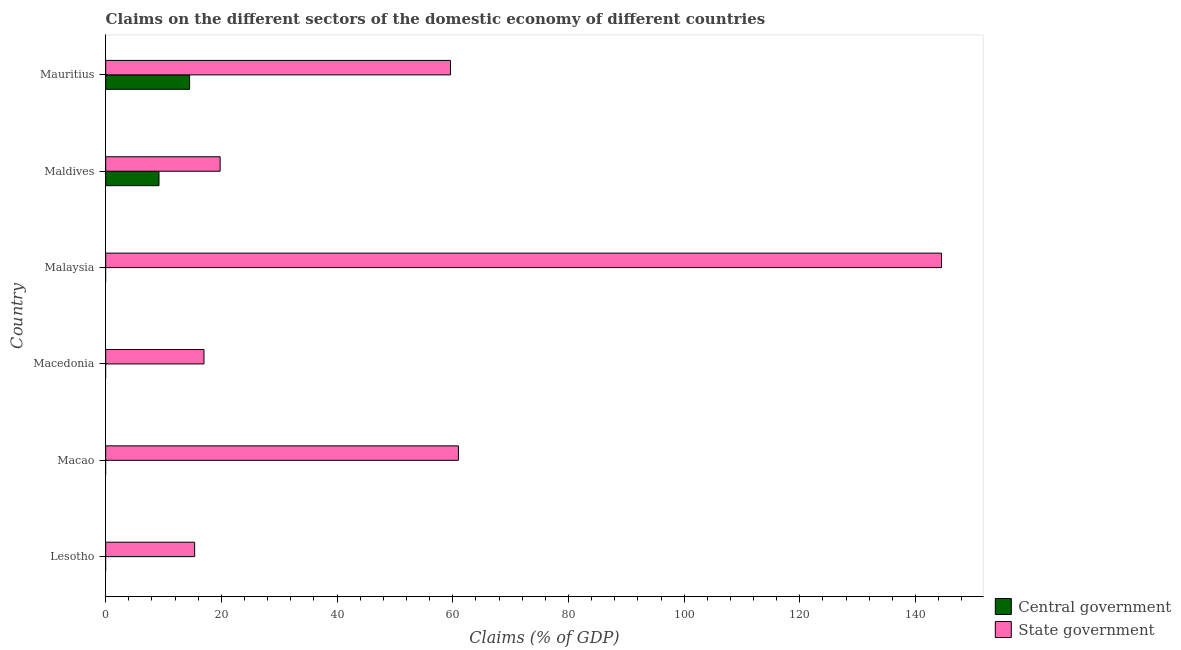How many different coloured bars are there?
Make the answer very short. 2. Are the number of bars on each tick of the Y-axis equal?
Offer a very short reply. No. What is the label of the 6th group of bars from the top?
Make the answer very short. Lesotho. In how many cases, is the number of bars for a given country not equal to the number of legend labels?
Your answer should be very brief. 4. What is the claims on state government in Malaysia?
Offer a terse response. 144.49. Across all countries, what is the maximum claims on state government?
Offer a very short reply. 144.49. In which country was the claims on state government maximum?
Provide a succinct answer. Malaysia. What is the total claims on state government in the graph?
Ensure brevity in your answer.  317.22. What is the difference between the claims on state government in Lesotho and that in Macedonia?
Provide a succinct answer. -1.61. What is the difference between the claims on state government in Malaysia and the claims on central government in Macao?
Provide a short and direct response. 144.49. What is the average claims on central government per country?
Make the answer very short. 3.95. What is the difference between the claims on central government and claims on state government in Mauritius?
Your response must be concise. -45.1. What is the ratio of the claims on state government in Malaysia to that in Mauritius?
Your response must be concise. 2.42. What is the difference between the highest and the second highest claims on state government?
Ensure brevity in your answer.  83.51. What is the difference between the highest and the lowest claims on state government?
Your response must be concise. 129.11. Is the sum of the claims on state government in Macao and Maldives greater than the maximum claims on central government across all countries?
Keep it short and to the point. Yes. How many bars are there?
Your answer should be very brief. 8. How many countries are there in the graph?
Your response must be concise. 6. Does the graph contain grids?
Keep it short and to the point. No. Where does the legend appear in the graph?
Your answer should be compact. Bottom right. How many legend labels are there?
Make the answer very short. 2. What is the title of the graph?
Your response must be concise. Claims on the different sectors of the domestic economy of different countries. What is the label or title of the X-axis?
Keep it short and to the point. Claims (% of GDP). What is the Claims (% of GDP) of State government in Lesotho?
Make the answer very short. 15.38. What is the Claims (% of GDP) of Central government in Macao?
Provide a succinct answer. 0. What is the Claims (% of GDP) of State government in Macao?
Offer a terse response. 60.98. What is the Claims (% of GDP) of Central government in Macedonia?
Offer a terse response. 0. What is the Claims (% of GDP) of State government in Macedonia?
Ensure brevity in your answer.  16.99. What is the Claims (% of GDP) in State government in Malaysia?
Give a very brief answer. 144.49. What is the Claims (% of GDP) in Central government in Maldives?
Ensure brevity in your answer.  9.21. What is the Claims (% of GDP) of State government in Maldives?
Provide a short and direct response. 19.78. What is the Claims (% of GDP) of Central government in Mauritius?
Keep it short and to the point. 14.51. What is the Claims (% of GDP) of State government in Mauritius?
Provide a short and direct response. 59.6. Across all countries, what is the maximum Claims (% of GDP) in Central government?
Your answer should be compact. 14.51. Across all countries, what is the maximum Claims (% of GDP) of State government?
Your answer should be compact. 144.49. Across all countries, what is the minimum Claims (% of GDP) of State government?
Offer a terse response. 15.38. What is the total Claims (% of GDP) in Central government in the graph?
Make the answer very short. 23.72. What is the total Claims (% of GDP) of State government in the graph?
Keep it short and to the point. 317.22. What is the difference between the Claims (% of GDP) of State government in Lesotho and that in Macao?
Provide a succinct answer. -45.6. What is the difference between the Claims (% of GDP) of State government in Lesotho and that in Macedonia?
Ensure brevity in your answer.  -1.61. What is the difference between the Claims (% of GDP) of State government in Lesotho and that in Malaysia?
Your answer should be compact. -129.11. What is the difference between the Claims (% of GDP) of State government in Lesotho and that in Maldives?
Ensure brevity in your answer.  -4.4. What is the difference between the Claims (% of GDP) of State government in Lesotho and that in Mauritius?
Offer a very short reply. -44.22. What is the difference between the Claims (% of GDP) of State government in Macao and that in Macedonia?
Offer a terse response. 43.99. What is the difference between the Claims (% of GDP) in State government in Macao and that in Malaysia?
Your answer should be compact. -83.51. What is the difference between the Claims (% of GDP) of State government in Macao and that in Maldives?
Your response must be concise. 41.2. What is the difference between the Claims (% of GDP) in State government in Macao and that in Mauritius?
Your answer should be very brief. 1.37. What is the difference between the Claims (% of GDP) in State government in Macedonia and that in Malaysia?
Keep it short and to the point. -127.5. What is the difference between the Claims (% of GDP) of State government in Macedonia and that in Maldives?
Ensure brevity in your answer.  -2.79. What is the difference between the Claims (% of GDP) in State government in Macedonia and that in Mauritius?
Provide a succinct answer. -42.62. What is the difference between the Claims (% of GDP) in State government in Malaysia and that in Maldives?
Make the answer very short. 124.7. What is the difference between the Claims (% of GDP) of State government in Malaysia and that in Mauritius?
Your answer should be compact. 84.88. What is the difference between the Claims (% of GDP) of Central government in Maldives and that in Mauritius?
Offer a terse response. -5.29. What is the difference between the Claims (% of GDP) in State government in Maldives and that in Mauritius?
Make the answer very short. -39.82. What is the difference between the Claims (% of GDP) in Central government in Maldives and the Claims (% of GDP) in State government in Mauritius?
Provide a succinct answer. -50.39. What is the average Claims (% of GDP) of Central government per country?
Keep it short and to the point. 3.95. What is the average Claims (% of GDP) of State government per country?
Offer a terse response. 52.87. What is the difference between the Claims (% of GDP) in Central government and Claims (% of GDP) in State government in Maldives?
Give a very brief answer. -10.57. What is the difference between the Claims (% of GDP) of Central government and Claims (% of GDP) of State government in Mauritius?
Your response must be concise. -45.1. What is the ratio of the Claims (% of GDP) of State government in Lesotho to that in Macao?
Offer a terse response. 0.25. What is the ratio of the Claims (% of GDP) in State government in Lesotho to that in Macedonia?
Your answer should be compact. 0.91. What is the ratio of the Claims (% of GDP) of State government in Lesotho to that in Malaysia?
Keep it short and to the point. 0.11. What is the ratio of the Claims (% of GDP) of State government in Lesotho to that in Maldives?
Offer a very short reply. 0.78. What is the ratio of the Claims (% of GDP) in State government in Lesotho to that in Mauritius?
Your answer should be compact. 0.26. What is the ratio of the Claims (% of GDP) in State government in Macao to that in Macedonia?
Ensure brevity in your answer.  3.59. What is the ratio of the Claims (% of GDP) in State government in Macao to that in Malaysia?
Provide a short and direct response. 0.42. What is the ratio of the Claims (% of GDP) in State government in Macao to that in Maldives?
Make the answer very short. 3.08. What is the ratio of the Claims (% of GDP) in State government in Macao to that in Mauritius?
Your answer should be very brief. 1.02. What is the ratio of the Claims (% of GDP) of State government in Macedonia to that in Malaysia?
Your answer should be compact. 0.12. What is the ratio of the Claims (% of GDP) of State government in Macedonia to that in Maldives?
Your response must be concise. 0.86. What is the ratio of the Claims (% of GDP) of State government in Macedonia to that in Mauritius?
Keep it short and to the point. 0.28. What is the ratio of the Claims (% of GDP) of State government in Malaysia to that in Maldives?
Your response must be concise. 7.3. What is the ratio of the Claims (% of GDP) in State government in Malaysia to that in Mauritius?
Ensure brevity in your answer.  2.42. What is the ratio of the Claims (% of GDP) in Central government in Maldives to that in Mauritius?
Your answer should be very brief. 0.64. What is the ratio of the Claims (% of GDP) of State government in Maldives to that in Mauritius?
Give a very brief answer. 0.33. What is the difference between the highest and the second highest Claims (% of GDP) of State government?
Ensure brevity in your answer.  83.51. What is the difference between the highest and the lowest Claims (% of GDP) of Central government?
Your response must be concise. 14.51. What is the difference between the highest and the lowest Claims (% of GDP) of State government?
Your response must be concise. 129.11. 